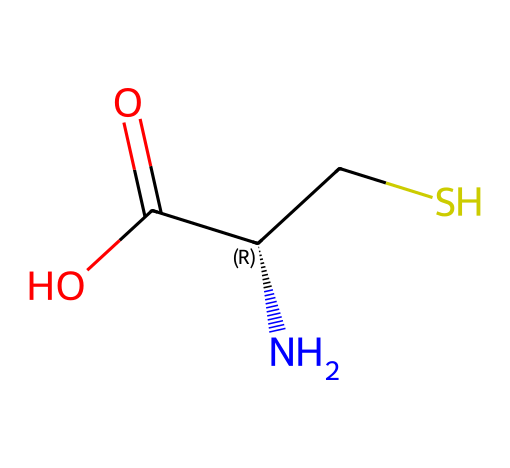What is the molecular formula of cysteine? The molecular formula can be derived from the SMILES representation. The components include 3 carbon atoms (C), 7 hydrogen atoms (H), 1 nitrogen atom (N), 2 oxygen atoms (O), and 1 sulfur atom (S). Therefore, the combined formula is C3H7N1O2S1.
Answer: C3H7NOS How many carbon atoms are present in cysteine? By examining the SMILES representation, there are three 'C' characters present in the structure, indicating that there are 3 carbon atoms.
Answer: 3 What characteristic functional group is found in cysteine? Cysteine contains a thiol (-SH) functional group, which is indicated by the "S" in the structure that connects to the carbon (CS). This is a defining feature of thiols or sulfhydryl compounds.
Answer: thiol What is the stereochemistry of the cysteine structure? The SMILES notation includes a stereocenter indicated by the "C@@H" portion, which reveals that cysteine has a specific stereochemistry, making it a chiral compound.
Answer: chiral Which part of cysteine contributes to its role in protein structure? The amino group (-NH2) and carboxylic acid group (-COOH) are crucial components for forming peptide bonds in proteins, allowing for linkage between amino acids. This structural role is vital in the context of proteins.
Answer: amino and carboxylic acid groups How many total atoms are there in the cysteine molecule? From the molecular formula C3H7NOS, count the total as 3 (C) + 7 (H) + 1 (N) + 2 (O) + 1 (S) = 14 total atoms in the molecule.
Answer: 14 